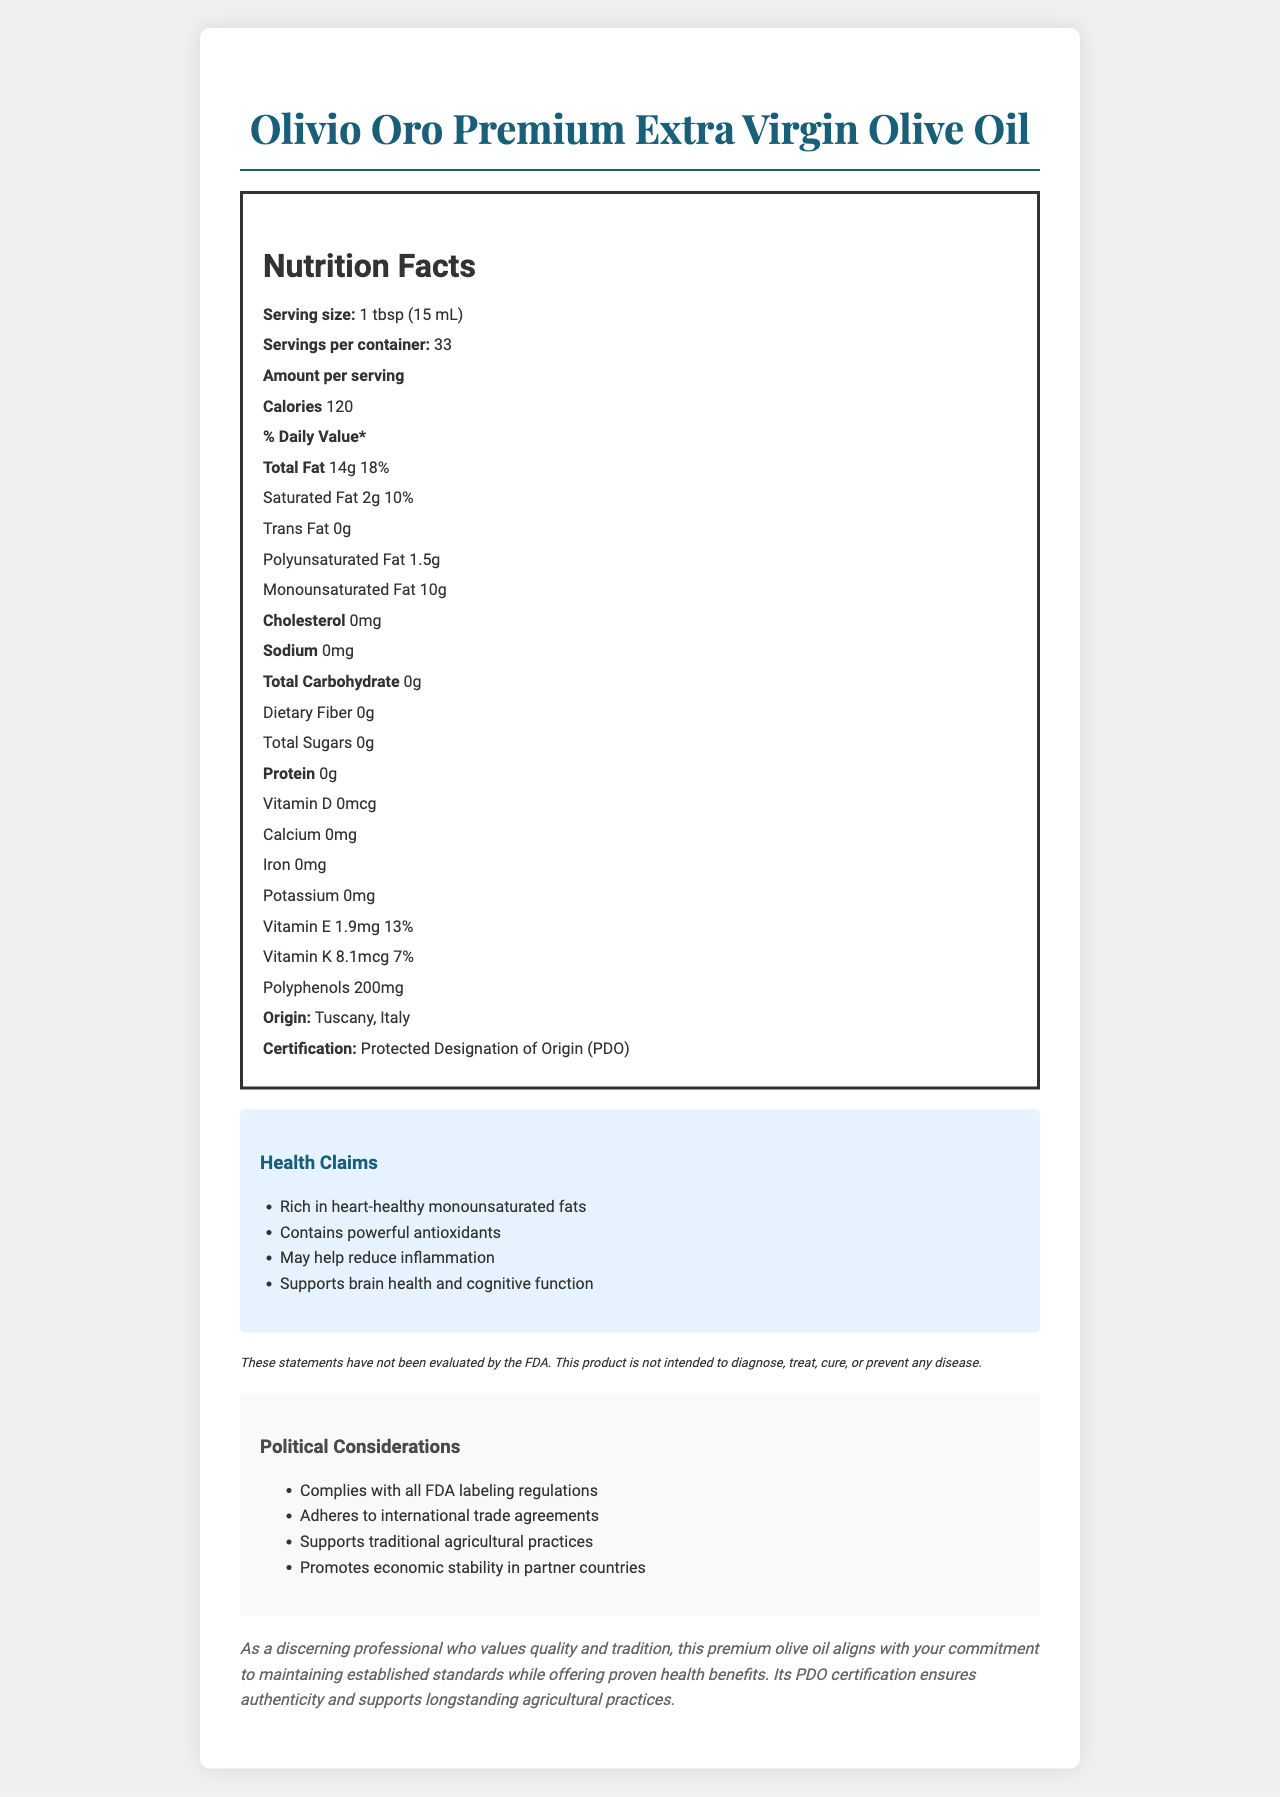what is the serving size? The serving size is explicitly mentioned in the document as "1 tbsp (15 mL)".
Answer: 1 tbsp (15 mL) how many grams of total fat are in one serving? The document states that the amount of total fat per serving is 14 grams.
Answer: 14g is there any cholesterol in this olive oil? The document lists the cholesterol content as "0mg", indicating there is no cholesterol.
Answer: No what is the percentage daily value of vitamin E per serving? The document lists vitamin E content as "1.9mg" with a daily value of 13%.
Answer: 13% how many servings are in one container? The document specifies that there are 33 servings per container.
Answer: 33 what type of fats are mostly found in this product?
A. Saturated Fat
B. Monounsaturated Fat
C. Polyunsaturated Fat
D. Trans Fat The document states that there are 10g of Monounsaturated Fat, which is the highest amount compared to other types of fats listed.
Answer: B which of the following health claims is NOT mentioned for this olive oil?
A. Supports brain health
B. Helps in weight loss
C. Contains powerful antioxidants
D. Rich in heart-healthy monounsaturated fats The health claims listed in the document include "Supports brain health", "Contains powerful antioxidants", and "Rich in heart-healthy monounsaturated fats" but not "Helps in weight loss".
Answer: B is this olive oil compliant with FDA labeling regulations? The document explicitly states that it complies with all FDA labeling regulations.
Answer: Yes summarize the main nutritional benefits of this olive oil. The main nutritional benefits are highlighted in the health claims and detailed in the nutritional content, such as the high monounsaturated fat content and antioxidants.
Answer: This premium olive oil is rich in heart-healthy monounsaturated fats, contains powerful antioxidants (polyphenols), has no cholesterol or trans fats, and offers some vitamins like vitamin E and K. how many grams of protein does this olive oil contain? The document states that the amount of protein per serving is 0 grams.
Answer: 0g what is the origin of this olive oil? The document specifies that the origin of the olive oil is Tuscany, Italy.
Answer: Tuscany, Italy what is the product name? The product name is clearly titled at the top of the document as "Olivio Oro Premium Extra Virgin Olive Oil".
Answer: Olivio Oro Premium Extra Virgin Olive Oil how does this product support economic stability? The document mentions that the political considerations include promoting economic stability in partner countries but does not provide details on how it specifically achieves this.
Answer: Not enough information 